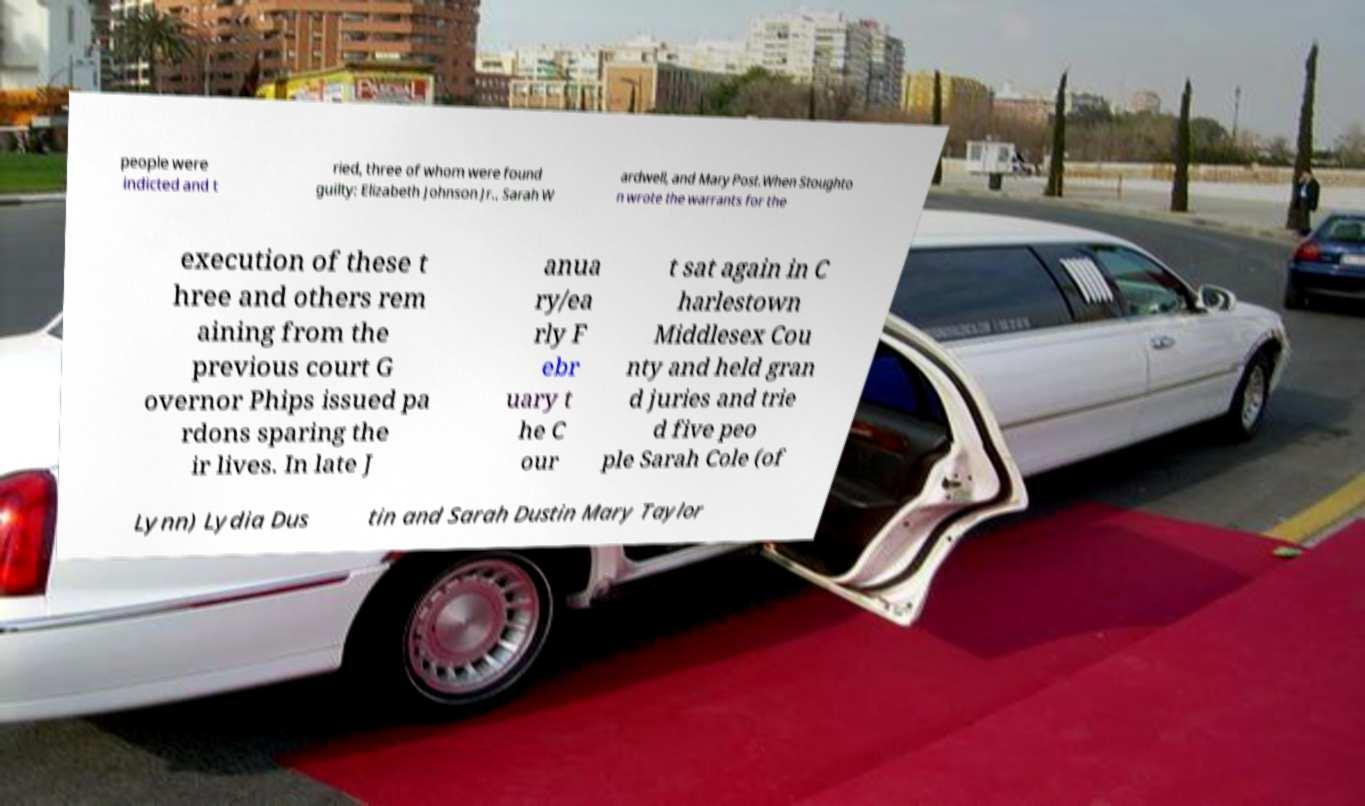Could you extract and type out the text from this image? people were indicted and t ried, three of whom were found guilty: Elizabeth Johnson Jr., Sarah W ardwell, and Mary Post.When Stoughto n wrote the warrants for the execution of these t hree and others rem aining from the previous court G overnor Phips issued pa rdons sparing the ir lives. In late J anua ry/ea rly F ebr uary t he C our t sat again in C harlestown Middlesex Cou nty and held gran d juries and trie d five peo ple Sarah Cole (of Lynn) Lydia Dus tin and Sarah Dustin Mary Taylor 